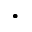<formula> <loc_0><loc_0><loc_500><loc_500>\cdot</formula> 